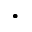<formula> <loc_0><loc_0><loc_500><loc_500>\cdot</formula> 